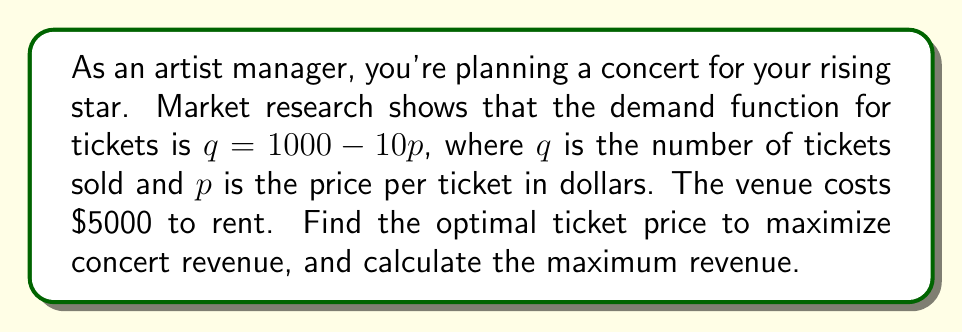What is the answer to this math problem? 1) First, let's set up the revenue function. Revenue is price times quantity minus costs:
   $R = pq - 5000$

2) Substitute the demand function into the revenue equation:
   $R = p(1000 - 10p) - 5000$
   $R = 1000p - 10p^2 - 5000$

3) This is a quadratic function. To find the maximum, we need to find the vertex of the parabola. We can do this by finding where the derivative equals zero.

4) Take the derivative of R with respect to p:
   $\frac{dR}{dp} = 1000 - 20p$

5) Set the derivative equal to zero and solve for p:
   $1000 - 20p = 0$
   $20p = 1000$
   $p = 50$

6) This gives us the optimal price of $50 per ticket.

7) To find the maximum revenue, plug this price back into the revenue function:
   $R = 1000(50) - 10(50)^2 - 5000$
   $R = 50000 - 25000 - 5000$
   $R = 20000$

Therefore, the maximum revenue is $20,000.
Answer: Optimal ticket price: $50; Maximum revenue: $20,000 